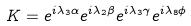<formula> <loc_0><loc_0><loc_500><loc_500>K = { e ^ { i { \lambda _ { 3 } } \alpha } } { e ^ { i { \lambda _ { 2 } } \beta } } { e ^ { i { \lambda _ { 3 } } \gamma } } { e ^ { i { \lambda _ { 8 } } \phi } }</formula> 